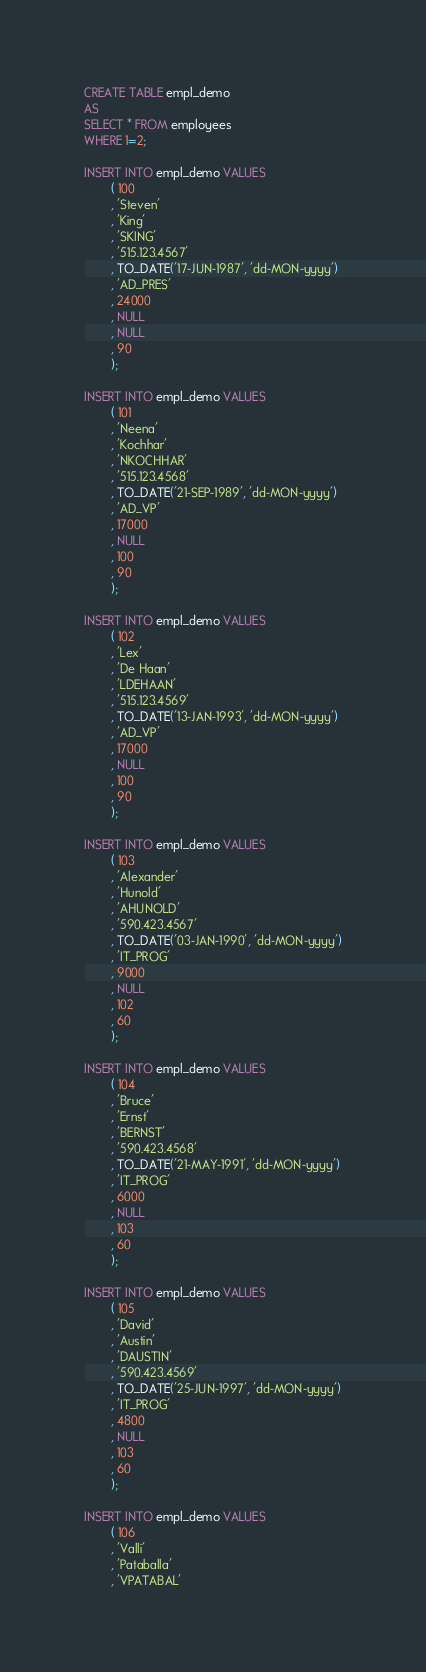<code> <loc_0><loc_0><loc_500><loc_500><_SQL_>CREATE TABLE empl_demo
AS
SELECT * FROM employees
WHERE 1=2;

INSERT INTO empl_demo VALUES 
        ( 100
        , 'Steven'
        , 'King'
        , 'SKING'
        , '515.123.4567'
        , TO_DATE('17-JUN-1987', 'dd-MON-yyyy')
        , 'AD_PRES'
        , 24000
        , NULL
        , NULL
        , 90
        );

INSERT INTO empl_demo VALUES 
        ( 101
        , 'Neena'
        , 'Kochhar'
        , 'NKOCHHAR'
        , '515.123.4568'
        , TO_DATE('21-SEP-1989', 'dd-MON-yyyy')
        , 'AD_VP'
        , 17000
        , NULL
        , 100
        , 90
        );

INSERT INTO empl_demo VALUES 
        ( 102
        , 'Lex'
        , 'De Haan'
        , 'LDEHAAN'
        , '515.123.4569'
        , TO_DATE('13-JAN-1993', 'dd-MON-yyyy')
        , 'AD_VP'
        , 17000
        , NULL
        , 100
        , 90
        );

INSERT INTO empl_demo VALUES 
        ( 103
        , 'Alexander'
        , 'Hunold'
        , 'AHUNOLD'
        , '590.423.4567'
        , TO_DATE('03-JAN-1990', 'dd-MON-yyyy')
        , 'IT_PROG'
        , 9000
        , NULL
        , 102
        , 60
        );

INSERT INTO empl_demo VALUES 
        ( 104
        , 'Bruce'
        , 'Ernst'
        , 'BERNST'
        , '590.423.4568'
        , TO_DATE('21-MAY-1991', 'dd-MON-yyyy')
        , 'IT_PROG'
        , 6000
        , NULL
        , 103
        , 60
        );

INSERT INTO empl_demo VALUES 
        ( 105
        , 'David'
        , 'Austin'
        , 'DAUSTIN'
        , '590.423.4569'
        , TO_DATE('25-JUN-1997', 'dd-MON-yyyy')
        , 'IT_PROG'
        , 4800
        , NULL
        , 103
        , 60
        );

INSERT INTO empl_demo VALUES 
        ( 106
        , 'Valli'
        , 'Pataballa'
        , 'VPATABAL'</code> 